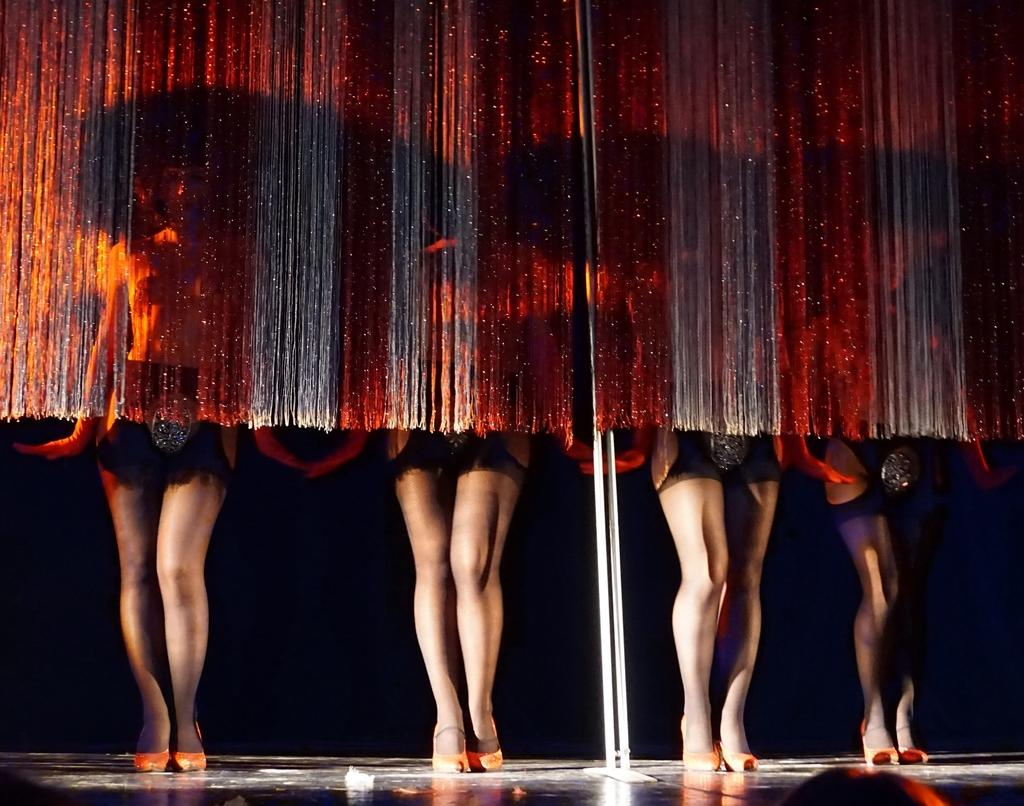What is the main subject of the image? The main subject of the image is the persons standing in the center. What can be seen in the background of the image? There is a pole in the image, with threads hanging from it. What is the surface on which the persons are standing? There is a floor visible in the image. How many dinosaurs can be seen in the image? There are no dinosaurs present in the image. Can you describe the behavior of the fly in the image? There is no fly present in the image. 